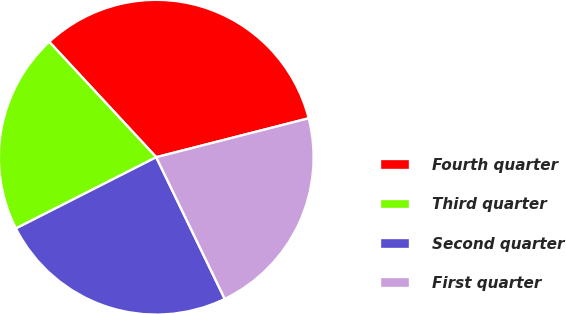Convert chart to OTSL. <chart><loc_0><loc_0><loc_500><loc_500><pie_chart><fcel>Fourth quarter<fcel>Third quarter<fcel>Second quarter<fcel>First quarter<nl><fcel>32.92%<fcel>20.58%<fcel>24.69%<fcel>21.81%<nl></chart> 